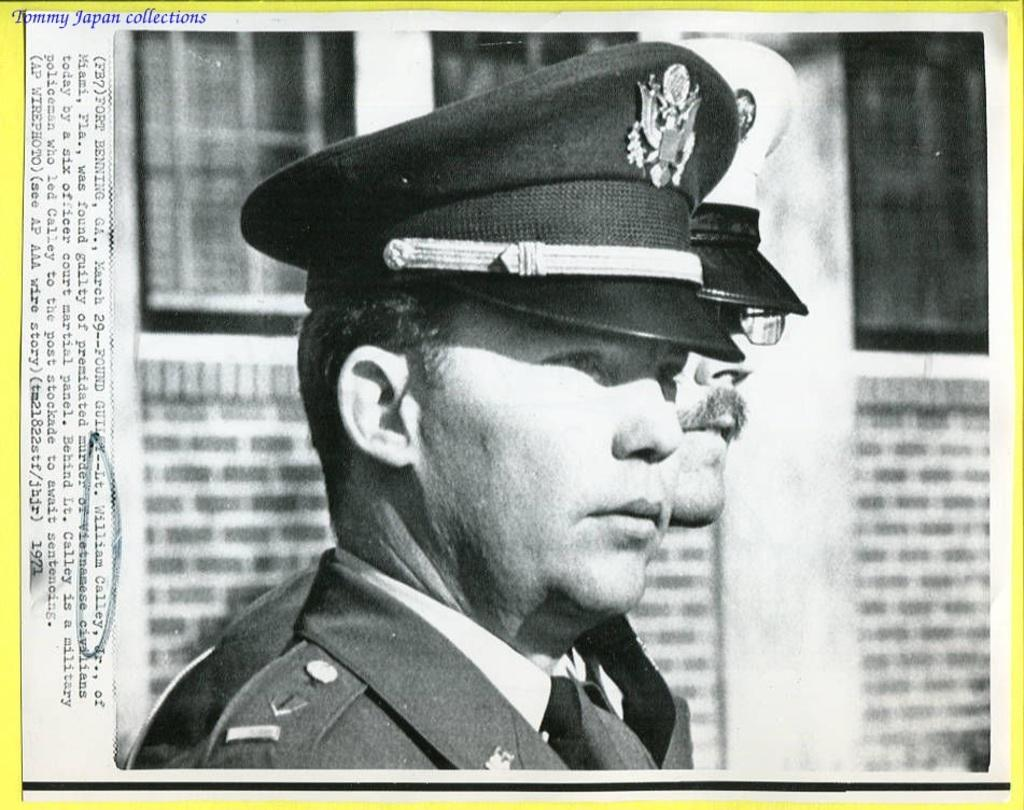How many people are in the image? There are two men in the center of the image. What are the men wearing on their heads? The men are wearing hats. What can be seen in the background of the image? There is a wall in the background of the image. Where is the text located in the image? The text is on the left side of the image. What type of oatmeal is being served in the image? There is no oatmeal present in the image. How many birds can be seen flying in the image? There are no birds visible in the image. 